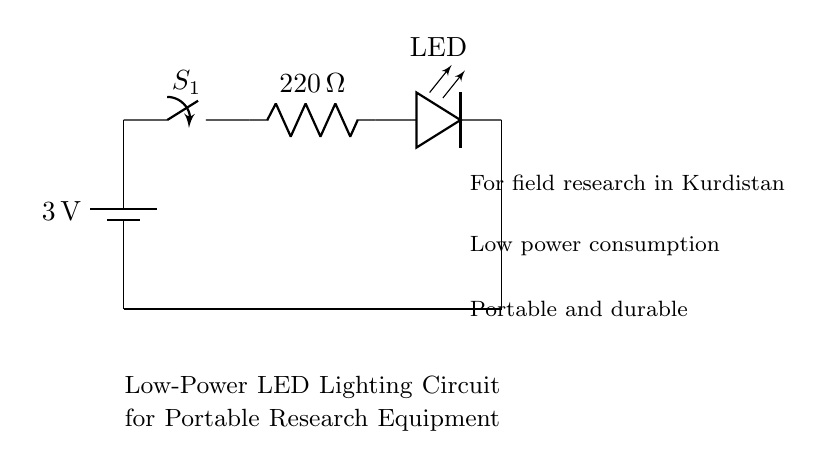What is the total voltage supplied by the battery? The circuit diagram shows a battery labeled with a voltage of 3 volts. This is the voltage supplied to the entire circuit.
Answer: 3 volts What is the resistance value in the circuit? The resistor in the circuit diagram is labeled with a value of 220 ohms. This is the resistance that restricts current flow in the circuit.
Answer: 220 ohms What type of lighting component is used in this circuit? The component labeled as LED indicates that the circuit uses a light-emitting diode for lighting purposes. This is the low-power lighting source.
Answer: LED How many components are connected in series in this circuit? The battery, switch, resistor, and LED are all connected in a single line without any branching, indicating they are in series. Therefore, there are four components in total.
Answer: 4 What is the purpose of the switch in this circuit? The switch allows for control over the current flow in the circuit. When closed, it completes the circuit and allows electricity to flow; when open, it interrupts the current. Hence, the switch is used for lighting control.
Answer: Control current What is the significance of using a low power circuit for field research? Low power consumption is crucial for portable equipment to prolong battery life during research activities. It ensures that the equipment remains functional over longer durations in the field.
Answer: Prolong battery life What is the expected application environment for this circuit? The circuit annotations indicate that it is designed for field research in Kurdistan, suggesting it is intended for outdoor or variable environmental conditions typical of research activities.
Answer: Field research in Kurdistan 